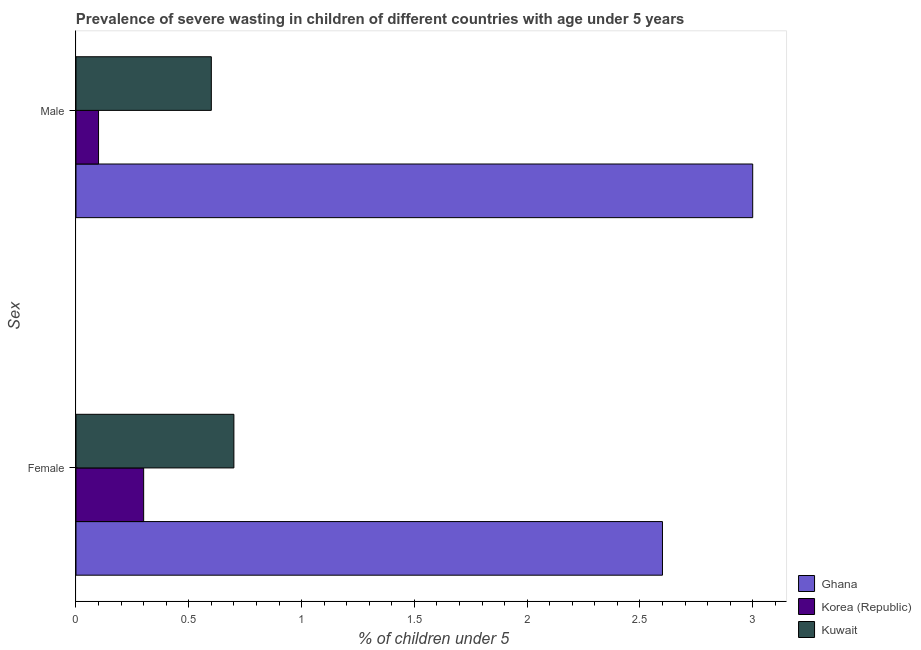How many different coloured bars are there?
Offer a terse response. 3. How many groups of bars are there?
Make the answer very short. 2. Are the number of bars on each tick of the Y-axis equal?
Your answer should be compact. Yes. How many bars are there on the 2nd tick from the top?
Offer a very short reply. 3. How many bars are there on the 2nd tick from the bottom?
Your response must be concise. 3. What is the percentage of undernourished female children in Kuwait?
Your answer should be very brief. 0.7. Across all countries, what is the maximum percentage of undernourished female children?
Ensure brevity in your answer.  2.6. Across all countries, what is the minimum percentage of undernourished male children?
Give a very brief answer. 0.1. What is the total percentage of undernourished female children in the graph?
Keep it short and to the point. 3.6. What is the difference between the percentage of undernourished female children in Korea (Republic) and that in Kuwait?
Provide a short and direct response. -0.4. What is the difference between the percentage of undernourished male children in Ghana and the percentage of undernourished female children in Kuwait?
Keep it short and to the point. 2.3. What is the average percentage of undernourished male children per country?
Offer a terse response. 1.23. What is the difference between the percentage of undernourished female children and percentage of undernourished male children in Korea (Republic)?
Your answer should be very brief. 0.2. What is the ratio of the percentage of undernourished male children in Kuwait to that in Korea (Republic)?
Offer a very short reply. 6. Is the percentage of undernourished female children in Kuwait less than that in Ghana?
Ensure brevity in your answer.  Yes. What does the 1st bar from the top in Female represents?
Make the answer very short. Kuwait. What does the 3rd bar from the bottom in Female represents?
Provide a succinct answer. Kuwait. How many countries are there in the graph?
Your response must be concise. 3. What is the difference between two consecutive major ticks on the X-axis?
Keep it short and to the point. 0.5. Does the graph contain grids?
Provide a succinct answer. No. Where does the legend appear in the graph?
Ensure brevity in your answer.  Bottom right. How are the legend labels stacked?
Give a very brief answer. Vertical. What is the title of the graph?
Give a very brief answer. Prevalence of severe wasting in children of different countries with age under 5 years. Does "Macao" appear as one of the legend labels in the graph?
Provide a succinct answer. No. What is the label or title of the X-axis?
Ensure brevity in your answer.   % of children under 5. What is the label or title of the Y-axis?
Provide a short and direct response. Sex. What is the  % of children under 5 in Ghana in Female?
Offer a terse response. 2.6. What is the  % of children under 5 in Korea (Republic) in Female?
Ensure brevity in your answer.  0.3. What is the  % of children under 5 of Kuwait in Female?
Offer a terse response. 0.7. What is the  % of children under 5 in Ghana in Male?
Your response must be concise. 3. What is the  % of children under 5 in Korea (Republic) in Male?
Keep it short and to the point. 0.1. What is the  % of children under 5 in Kuwait in Male?
Provide a succinct answer. 0.6. Across all Sex, what is the maximum  % of children under 5 in Korea (Republic)?
Provide a short and direct response. 0.3. Across all Sex, what is the maximum  % of children under 5 in Kuwait?
Offer a terse response. 0.7. Across all Sex, what is the minimum  % of children under 5 in Ghana?
Make the answer very short. 2.6. Across all Sex, what is the minimum  % of children under 5 of Korea (Republic)?
Make the answer very short. 0.1. Across all Sex, what is the minimum  % of children under 5 in Kuwait?
Provide a short and direct response. 0.6. What is the difference between the  % of children under 5 of Kuwait in Female and that in Male?
Give a very brief answer. 0.1. What is the difference between the  % of children under 5 of Korea (Republic) in Female and the  % of children under 5 of Kuwait in Male?
Provide a succinct answer. -0.3. What is the average  % of children under 5 of Korea (Republic) per Sex?
Keep it short and to the point. 0.2. What is the average  % of children under 5 in Kuwait per Sex?
Make the answer very short. 0.65. What is the difference between the  % of children under 5 of Ghana and  % of children under 5 of Kuwait in Female?
Offer a very short reply. 1.9. What is the difference between the  % of children under 5 in Korea (Republic) and  % of children under 5 in Kuwait in Male?
Provide a succinct answer. -0.5. What is the ratio of the  % of children under 5 in Ghana in Female to that in Male?
Provide a short and direct response. 0.87. What is the ratio of the  % of children under 5 in Korea (Republic) in Female to that in Male?
Give a very brief answer. 3. What is the ratio of the  % of children under 5 in Kuwait in Female to that in Male?
Your answer should be very brief. 1.17. What is the difference between the highest and the second highest  % of children under 5 in Ghana?
Keep it short and to the point. 0.4. What is the difference between the highest and the second highest  % of children under 5 in Korea (Republic)?
Your answer should be compact. 0.2. What is the difference between the highest and the lowest  % of children under 5 of Kuwait?
Provide a short and direct response. 0.1. 